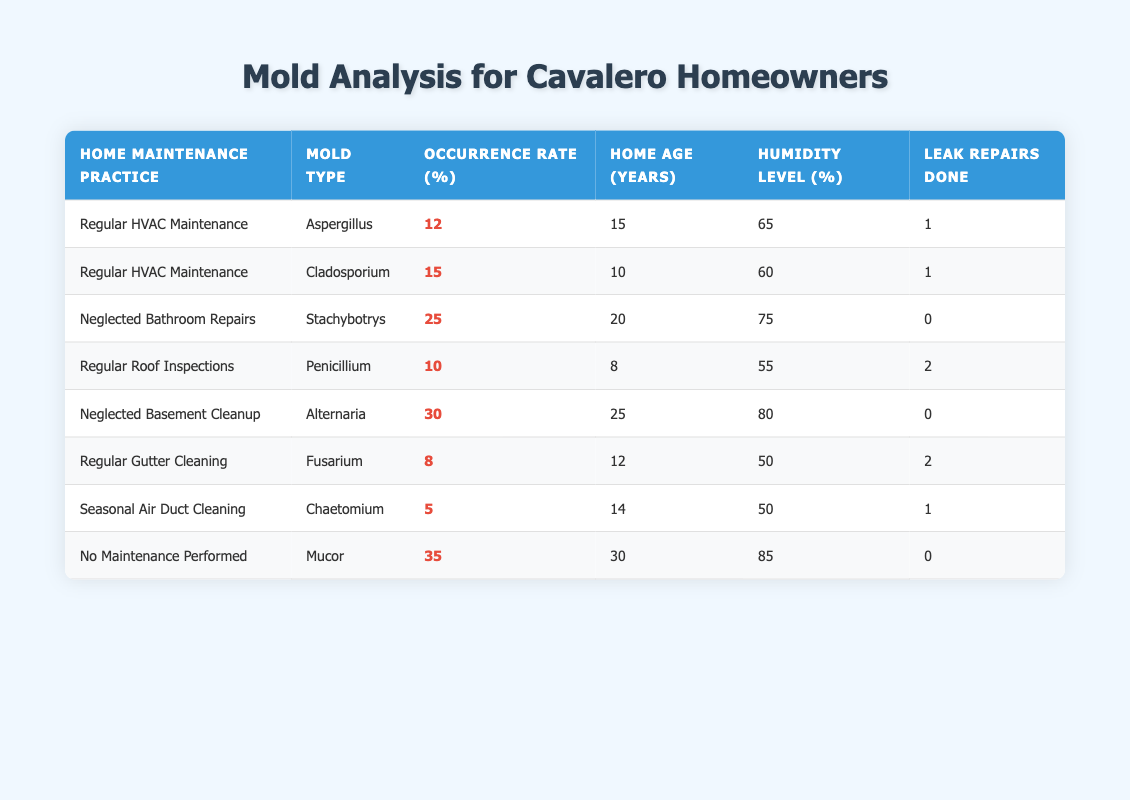What is the occurrence rate of Aspergillus? The table shows a row for Aspergillus under the "Regular HVAC Maintenance" practice with an occurrence rate of 12%. Therefore, this value can be directly retrieved from the table.
Answer: 12% Which mold type has the highest occurrence rate? By scanning through the "Occurrence Rate (%)" column, we see that "Mucor" has the highest occurrence rate at 35%. This is the only value in the table that is greater than all others.
Answer: Mucor Is there a correlation between humidity level and occurrence rate? To determine this, we should analyze the data. For instance, Mucor has an 85% humidity level and a 35% occurrence rate, while Fusarium has a 50% humidity level but a lower occurrence rate of 8%. These inconsistent patterns suggest no clear correlation.
Answer: No What is the average occurrence rate of molds associated with "Neglected Bathroom Repairs"? The occurrence rate of molds associated with "Neglected Bathroom Repairs" is 25% from Stachybotrys. Since there is only one entry under this maintenance practice, the average is simply 25%.
Answer: 25% How many leak repairs were done on homes where Stachybotrys was found? The data indicates that no leak repairs were done (0) in the row corresponding to Stachybotrys under "Neglected Bathroom Repairs." This fact can be directly referenced from that specific row.
Answer: 0 What is the difference between the average humidity level of homes with "No Maintenance Performed" and those with "Regular HVAC Maintenance"? The average humidity level for “No Maintenance Performed” (85% for Mucor) and for “Regular HVAC Maintenance” needs to be calculated. The average for "Regular HVAC Maintenance" (65% for Aspergillus and 60% for Cladosporium) is (65 + 60)/2 = 62.5%. The difference is 85% - 62.5% = 22.5%.
Answer: 22.5% Was there at least one mold type that had an occurrence rate above 20% under the maintenance practice "Regular Roof Inspections"? According to the table, the only mold under "Regular Roof Inspections" is Penicillium, with an occurrence rate of 10%. Since this is below 20%, the answer is no.
Answer: No How many home maintenance practices had an occurrence rate of mold types below 10%? Analyzing the table shows that both Fusarium and Chaetomium have occurrence rates of 8% and 5% respectively. Hence, there are two practices (Fusarium and Chaetomium) with occurrence rates below 10%.
Answer: 2 